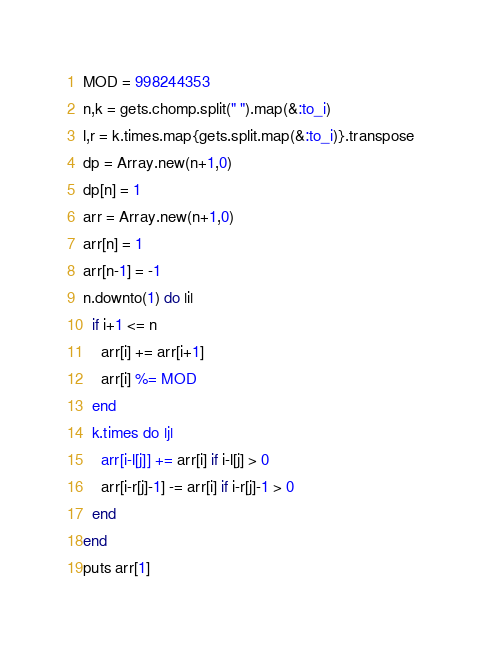<code> <loc_0><loc_0><loc_500><loc_500><_Ruby_>MOD = 998244353
n,k = gets.chomp.split(" ").map(&:to_i)
l,r = k.times.map{gets.split.map(&:to_i)}.transpose
dp = Array.new(n+1,0)
dp[n] = 1
arr = Array.new(n+1,0)
arr[n] = 1
arr[n-1] = -1
n.downto(1) do |i|
  if i+1 <= n
    arr[i] += arr[i+1]
    arr[i] %= MOD
  end
  k.times do |j|
    arr[i-l[j]] += arr[i] if i-l[j] > 0
    arr[i-r[j]-1] -= arr[i] if i-r[j]-1 > 0
  end
end
puts arr[1]</code> 